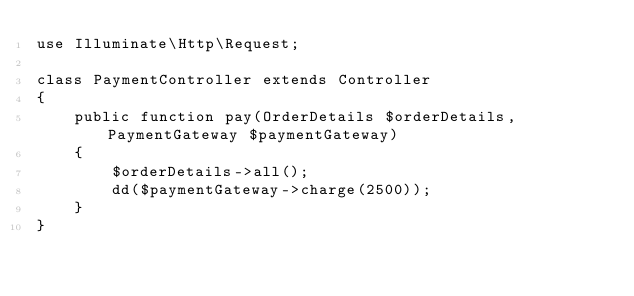<code> <loc_0><loc_0><loc_500><loc_500><_PHP_>use Illuminate\Http\Request;

class PaymentController extends Controller
{
    public function pay(OrderDetails $orderDetails, PaymentGateway $paymentGateway)
    {
        $orderDetails->all();
        dd($paymentGateway->charge(2500));
    }
}
</code> 